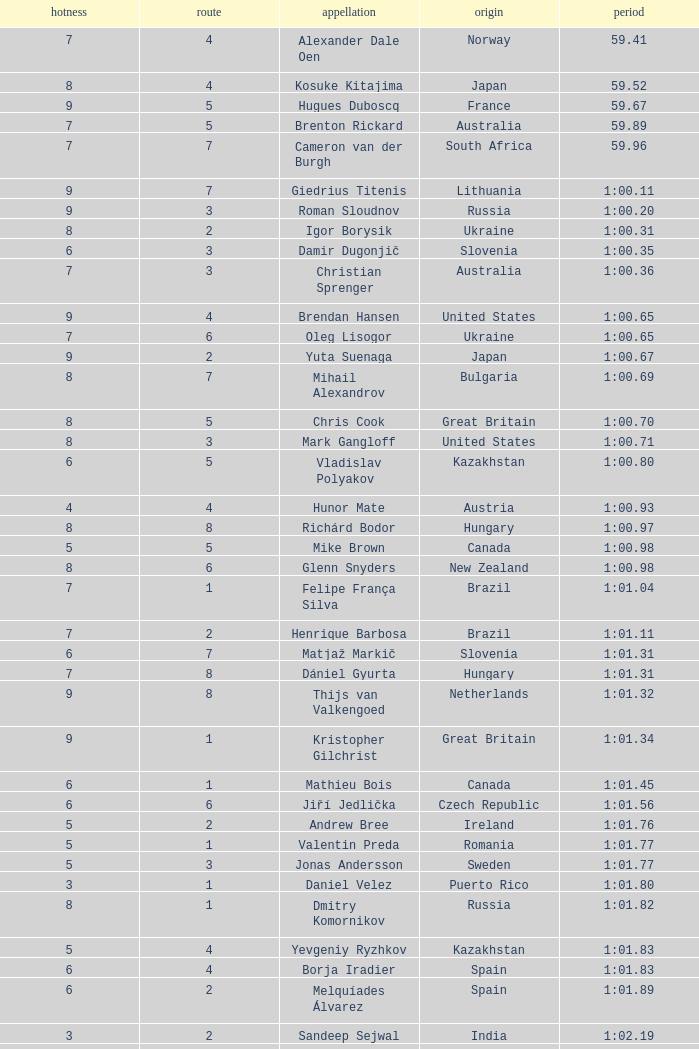What is the smallest lane number of Xue Ruipeng? 8.0. 